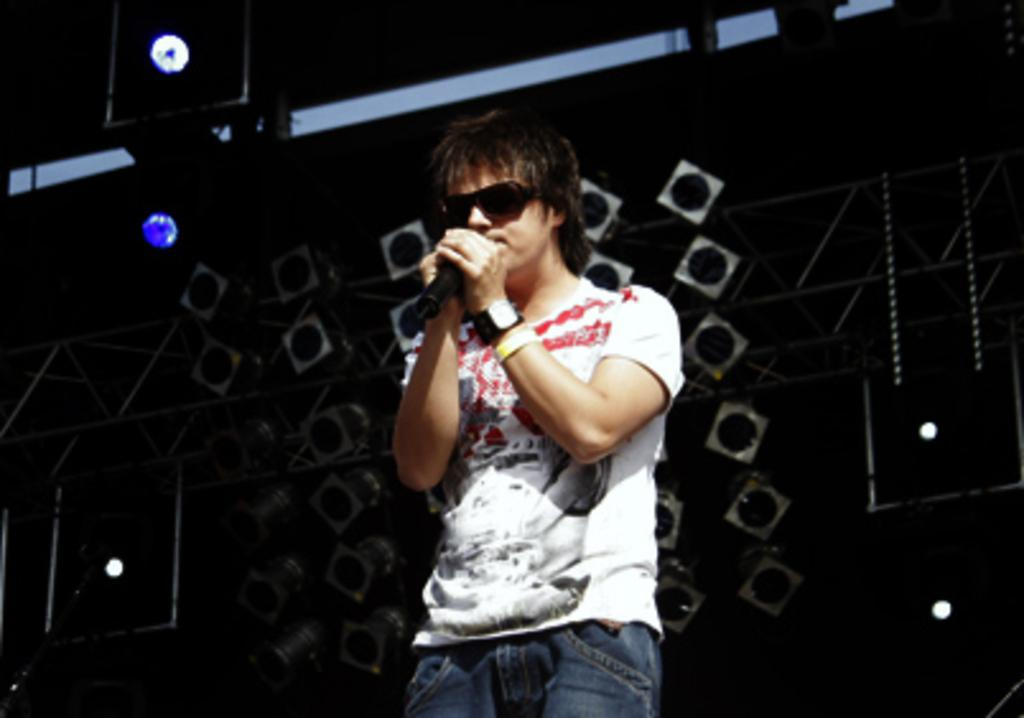What is the man in the image doing? The man is singing a song. What object is the man holding in the image? The man is holding a microphone. What type of clothing is the man wearing on his wrist? The man is wearing a wrist watch. What type of clothing is the man wearing on his upper body? The man is wearing a T-shirt. What can be seen in the background of the image? There is a light wall and a dark wall in the background. What type of flame can be seen coming from the man's mouth in the image? There is no flame present in the image; the man is singing with a microphone. What type of clam is visible on the floor in the image? There is no clam present in the image; the floor is not visible in the image. 